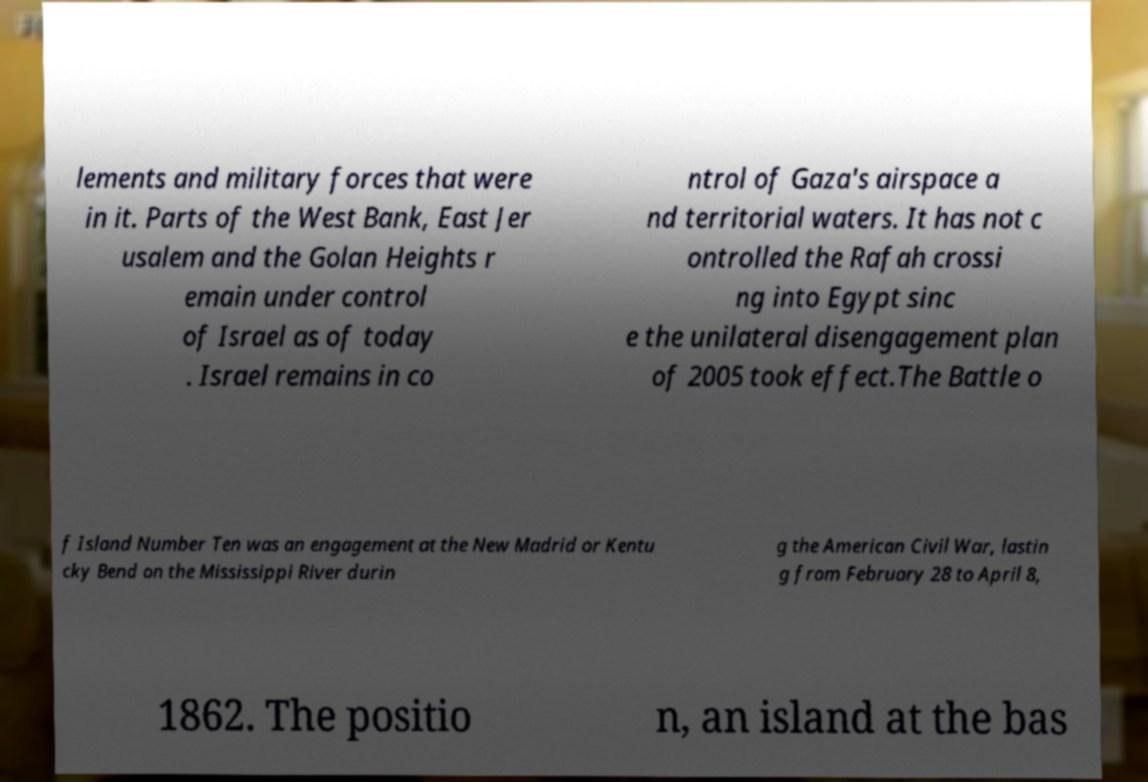Could you extract and type out the text from this image? lements and military forces that were in it. Parts of the West Bank, East Jer usalem and the Golan Heights r emain under control of Israel as of today . Israel remains in co ntrol of Gaza's airspace a nd territorial waters. It has not c ontrolled the Rafah crossi ng into Egypt sinc e the unilateral disengagement plan of 2005 took effect.The Battle o f Island Number Ten was an engagement at the New Madrid or Kentu cky Bend on the Mississippi River durin g the American Civil War, lastin g from February 28 to April 8, 1862. The positio n, an island at the bas 